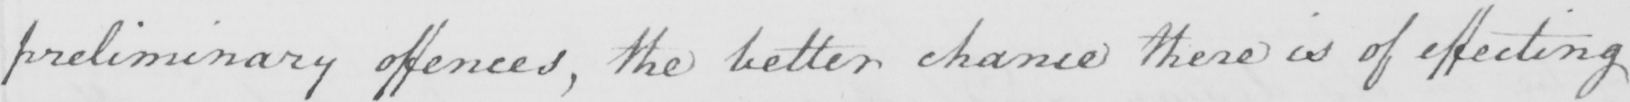Can you read and transcribe this handwriting? preliminary offences, the better chance there is of effecting 